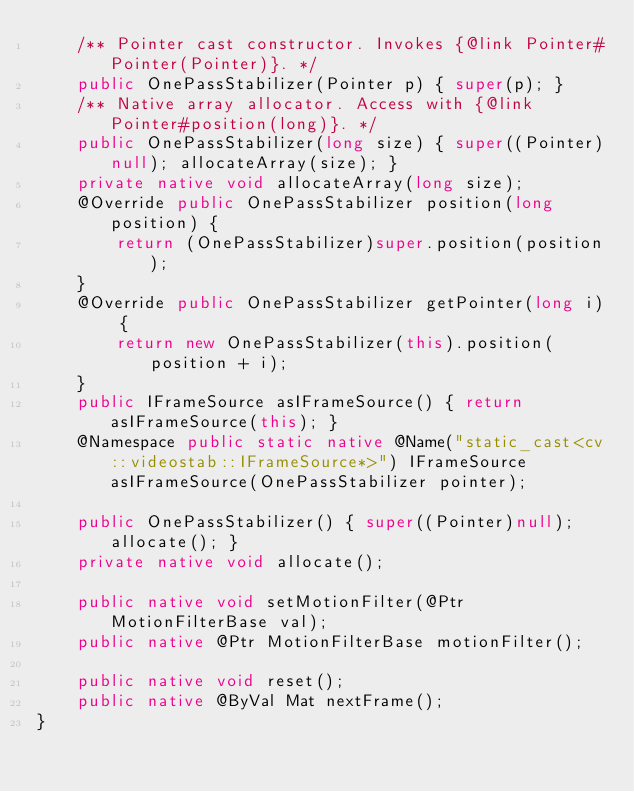<code> <loc_0><loc_0><loc_500><loc_500><_Java_>    /** Pointer cast constructor. Invokes {@link Pointer#Pointer(Pointer)}. */
    public OnePassStabilizer(Pointer p) { super(p); }
    /** Native array allocator. Access with {@link Pointer#position(long)}. */
    public OnePassStabilizer(long size) { super((Pointer)null); allocateArray(size); }
    private native void allocateArray(long size);
    @Override public OnePassStabilizer position(long position) {
        return (OnePassStabilizer)super.position(position);
    }
    @Override public OnePassStabilizer getPointer(long i) {
        return new OnePassStabilizer(this).position(position + i);
    }
    public IFrameSource asIFrameSource() { return asIFrameSource(this); }
    @Namespace public static native @Name("static_cast<cv::videostab::IFrameSource*>") IFrameSource asIFrameSource(OnePassStabilizer pointer);

    public OnePassStabilizer() { super((Pointer)null); allocate(); }
    private native void allocate();

    public native void setMotionFilter(@Ptr MotionFilterBase val);
    public native @Ptr MotionFilterBase motionFilter();

    public native void reset();
    public native @ByVal Mat nextFrame();
}
</code> 